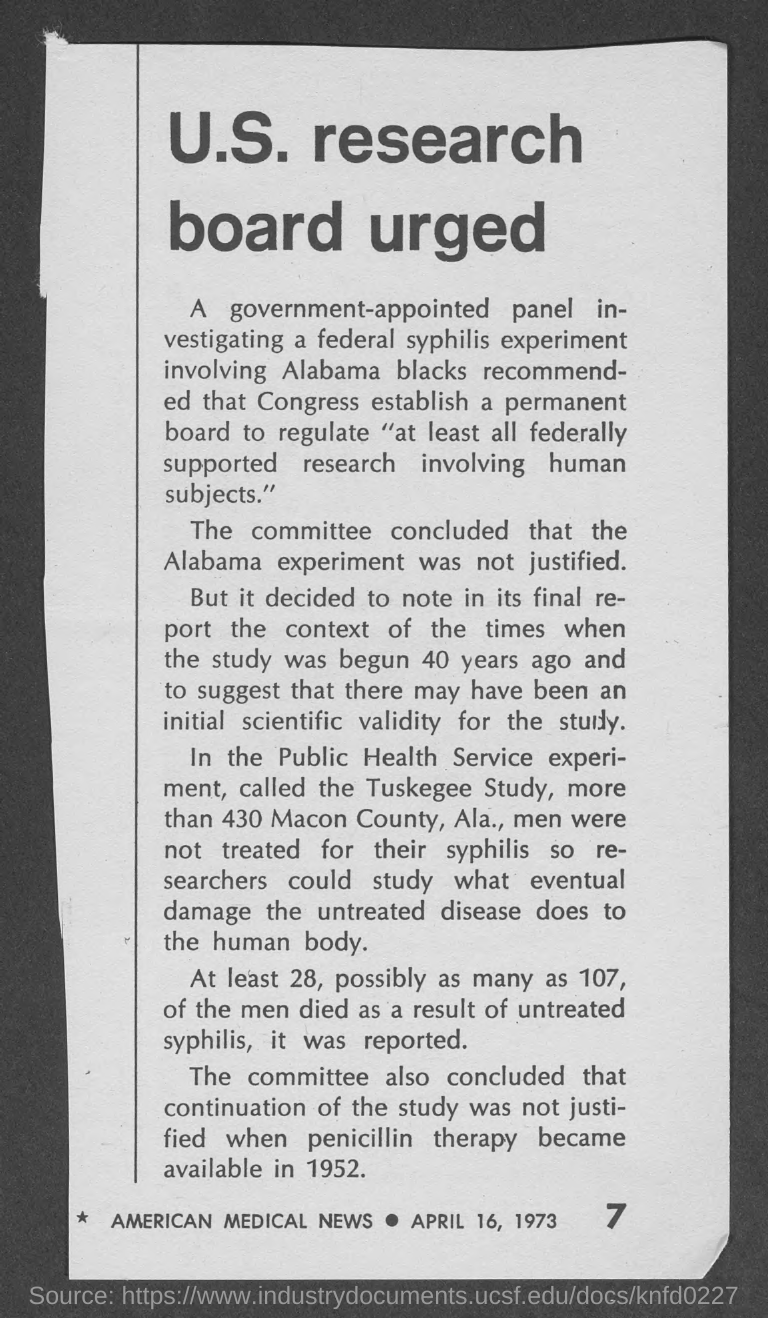When did pencillin therapy became available?
Offer a very short reply. 1952. What is the date on the document?
Offer a very short reply. April 16, 1973. 